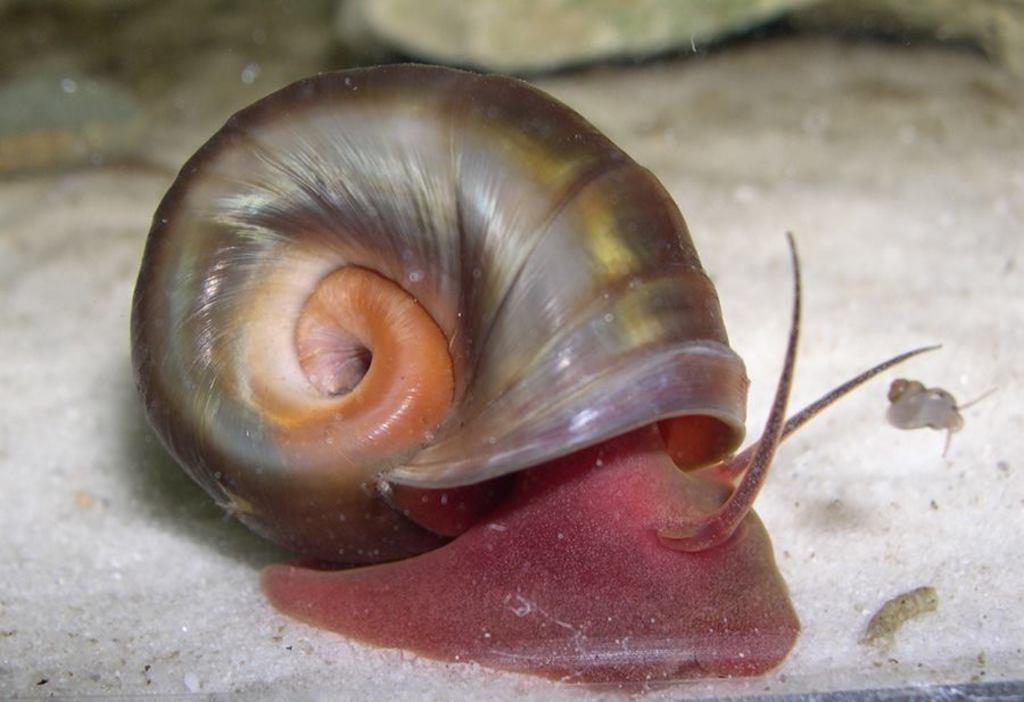Can you describe this image briefly? In the picture I can see snail. 